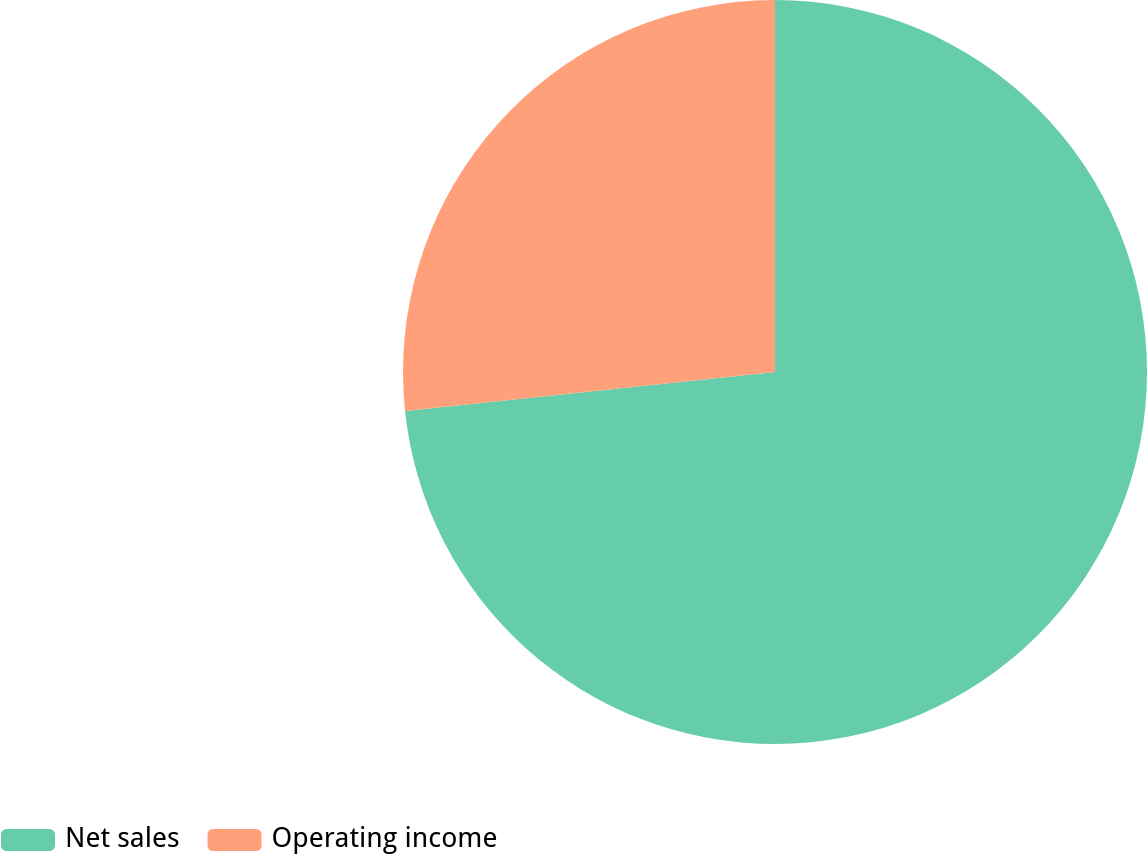<chart> <loc_0><loc_0><loc_500><loc_500><pie_chart><fcel>Net sales<fcel>Operating income<nl><fcel>73.33%<fcel>26.67%<nl></chart> 